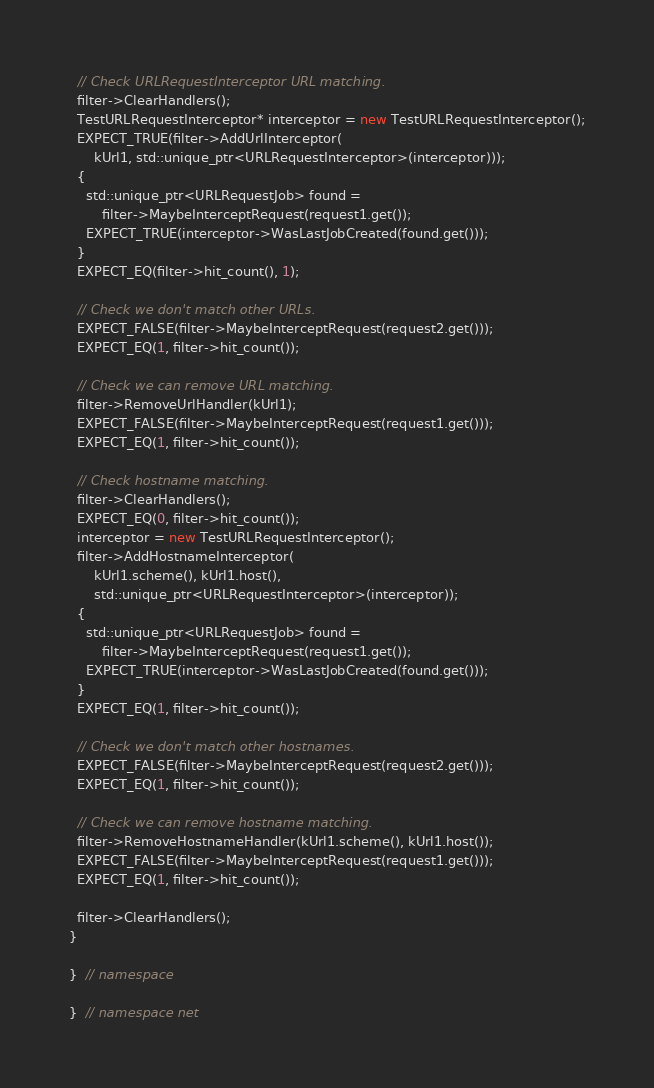Convert code to text. <code><loc_0><loc_0><loc_500><loc_500><_C++_>  // Check URLRequestInterceptor URL matching.
  filter->ClearHandlers();
  TestURLRequestInterceptor* interceptor = new TestURLRequestInterceptor();
  EXPECT_TRUE(filter->AddUrlInterceptor(
      kUrl1, std::unique_ptr<URLRequestInterceptor>(interceptor)));
  {
    std::unique_ptr<URLRequestJob> found =
        filter->MaybeInterceptRequest(request1.get());
    EXPECT_TRUE(interceptor->WasLastJobCreated(found.get()));
  }
  EXPECT_EQ(filter->hit_count(), 1);

  // Check we don't match other URLs.
  EXPECT_FALSE(filter->MaybeInterceptRequest(request2.get()));
  EXPECT_EQ(1, filter->hit_count());

  // Check we can remove URL matching.
  filter->RemoveUrlHandler(kUrl1);
  EXPECT_FALSE(filter->MaybeInterceptRequest(request1.get()));
  EXPECT_EQ(1, filter->hit_count());

  // Check hostname matching.
  filter->ClearHandlers();
  EXPECT_EQ(0, filter->hit_count());
  interceptor = new TestURLRequestInterceptor();
  filter->AddHostnameInterceptor(
      kUrl1.scheme(), kUrl1.host(),
      std::unique_ptr<URLRequestInterceptor>(interceptor));
  {
    std::unique_ptr<URLRequestJob> found =
        filter->MaybeInterceptRequest(request1.get());
    EXPECT_TRUE(interceptor->WasLastJobCreated(found.get()));
  }
  EXPECT_EQ(1, filter->hit_count());

  // Check we don't match other hostnames.
  EXPECT_FALSE(filter->MaybeInterceptRequest(request2.get()));
  EXPECT_EQ(1, filter->hit_count());

  // Check we can remove hostname matching.
  filter->RemoveHostnameHandler(kUrl1.scheme(), kUrl1.host());
  EXPECT_FALSE(filter->MaybeInterceptRequest(request1.get()));
  EXPECT_EQ(1, filter->hit_count());

  filter->ClearHandlers();
}

}  // namespace

}  // namespace net
</code> 